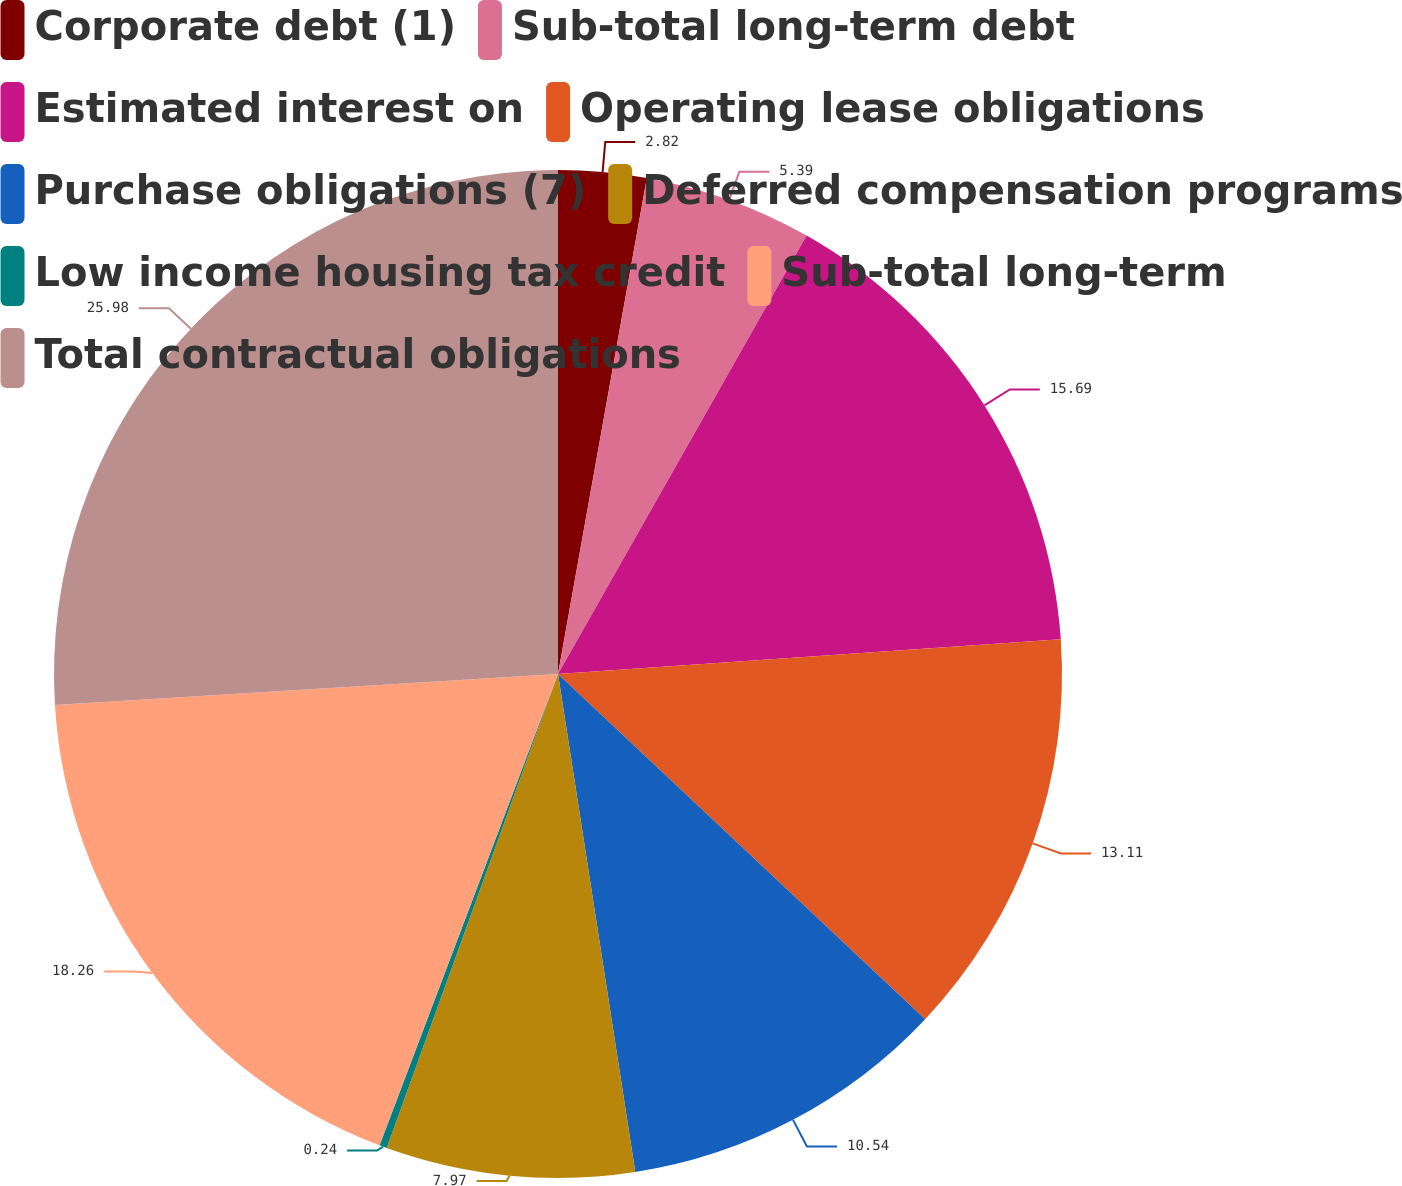<chart> <loc_0><loc_0><loc_500><loc_500><pie_chart><fcel>Corporate debt (1)<fcel>Sub-total long-term debt<fcel>Estimated interest on<fcel>Operating lease obligations<fcel>Purchase obligations (7)<fcel>Deferred compensation programs<fcel>Low income housing tax credit<fcel>Sub-total long-term<fcel>Total contractual obligations<nl><fcel>2.82%<fcel>5.39%<fcel>15.69%<fcel>13.11%<fcel>10.54%<fcel>7.97%<fcel>0.24%<fcel>18.26%<fcel>25.98%<nl></chart> 